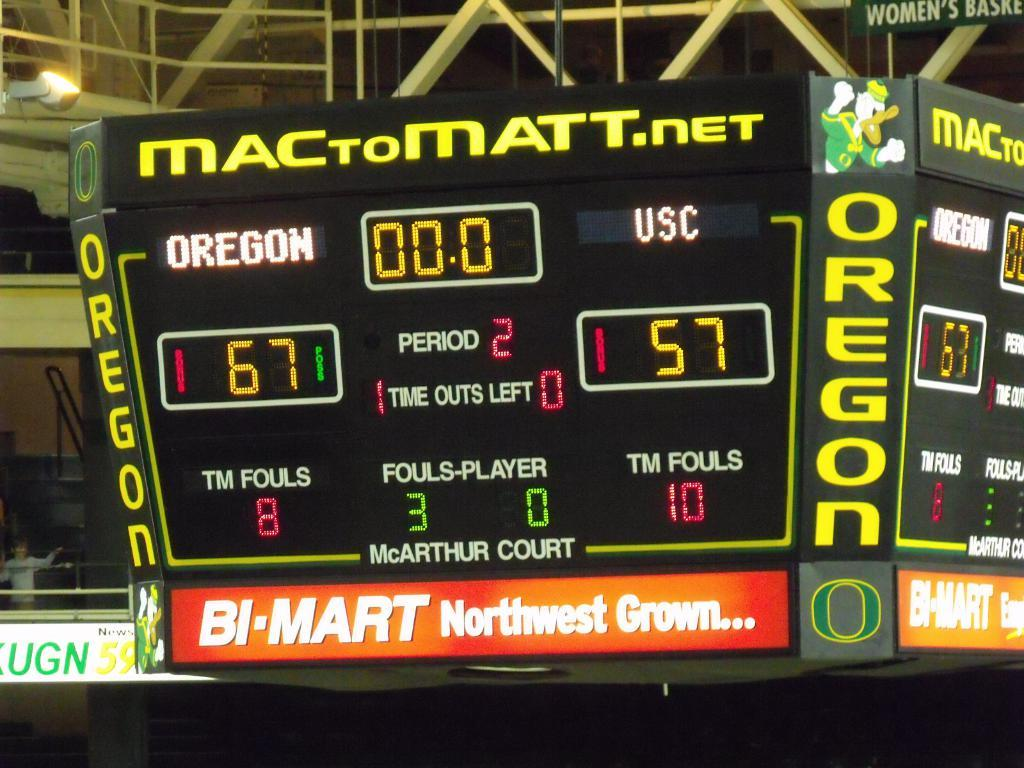<image>
Present a compact description of the photo's key features. A scoreboard in a sports arena for the game between Oregon and USC. 